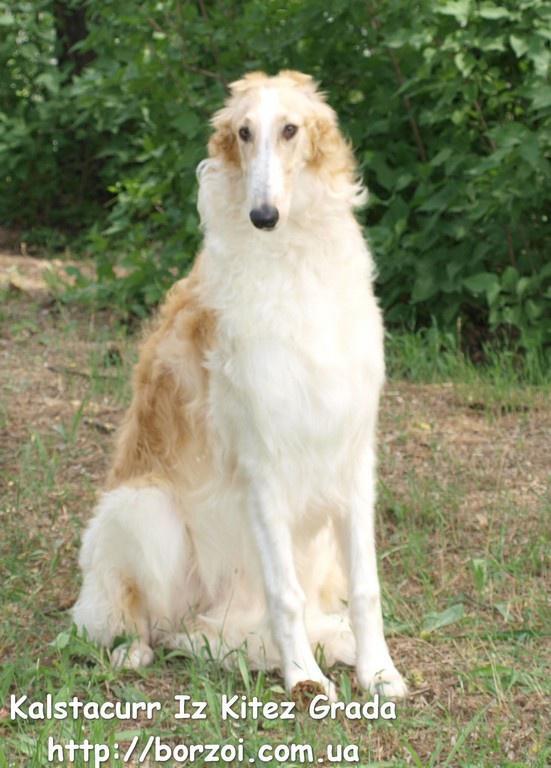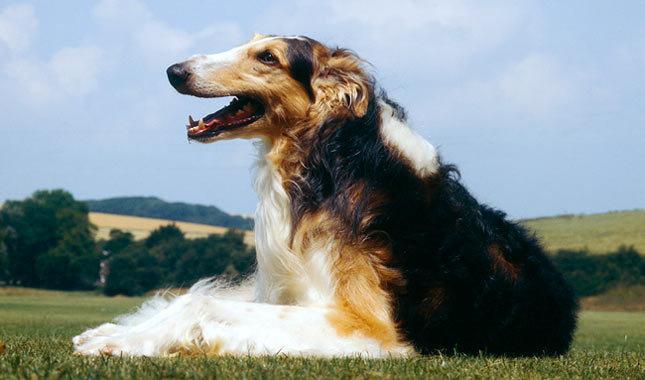The first image is the image on the left, the second image is the image on the right. Considering the images on both sides, is "The dog in one of the images is lying down on a piece of furniture." valid? Answer yes or no. No. 